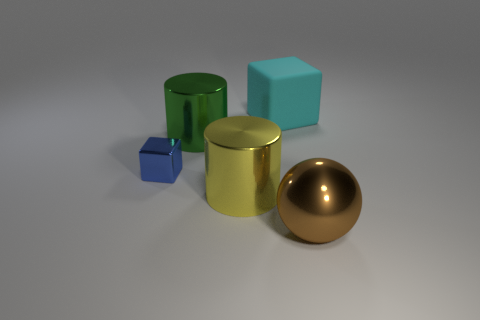Add 4 spheres. How many objects exist? 9 Subtract all cubes. How many objects are left? 3 Subtract 0 gray spheres. How many objects are left? 5 Subtract all gray shiny objects. Subtract all tiny metal things. How many objects are left? 4 Add 3 cyan matte cubes. How many cyan matte cubes are left? 4 Add 1 cyan shiny balls. How many cyan shiny balls exist? 1 